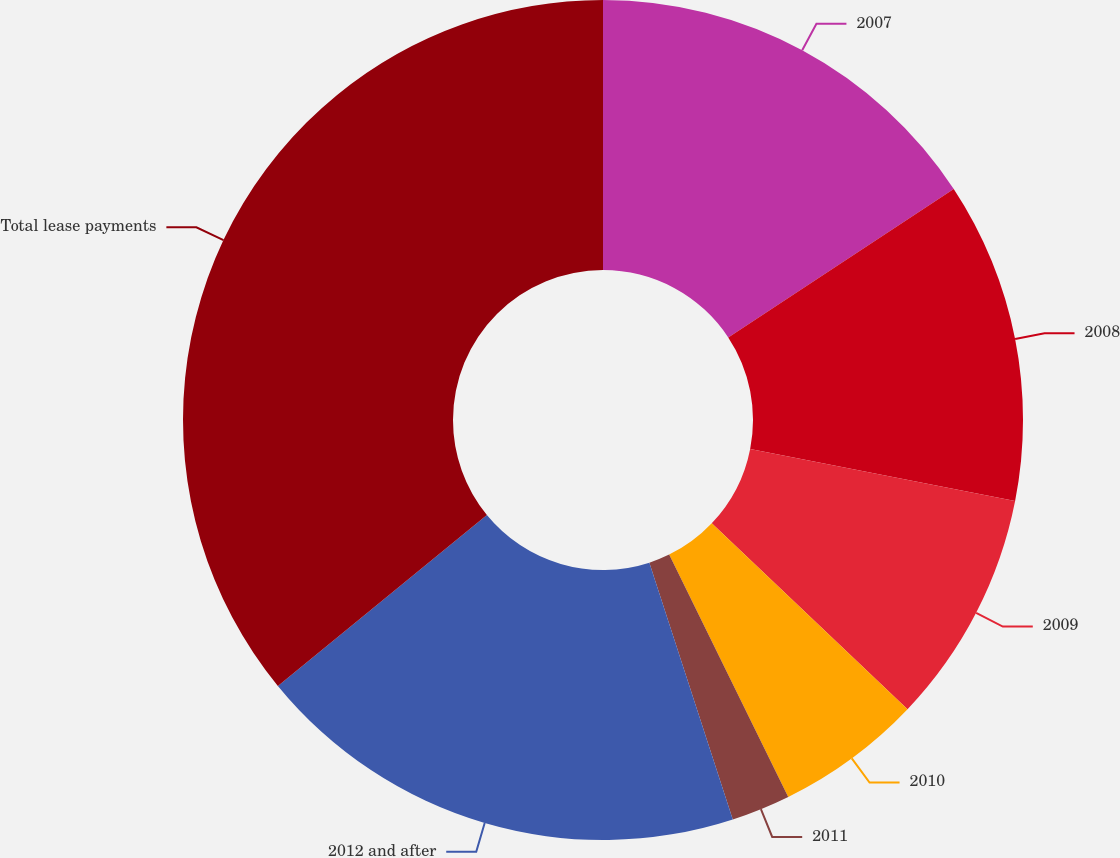Convert chart to OTSL. <chart><loc_0><loc_0><loc_500><loc_500><pie_chart><fcel>2007<fcel>2008<fcel>2009<fcel>2010<fcel>2011<fcel>2012 and after<fcel>Total lease payments<nl><fcel>15.73%<fcel>12.36%<fcel>9.0%<fcel>5.64%<fcel>2.27%<fcel>19.09%<fcel>35.91%<nl></chart> 